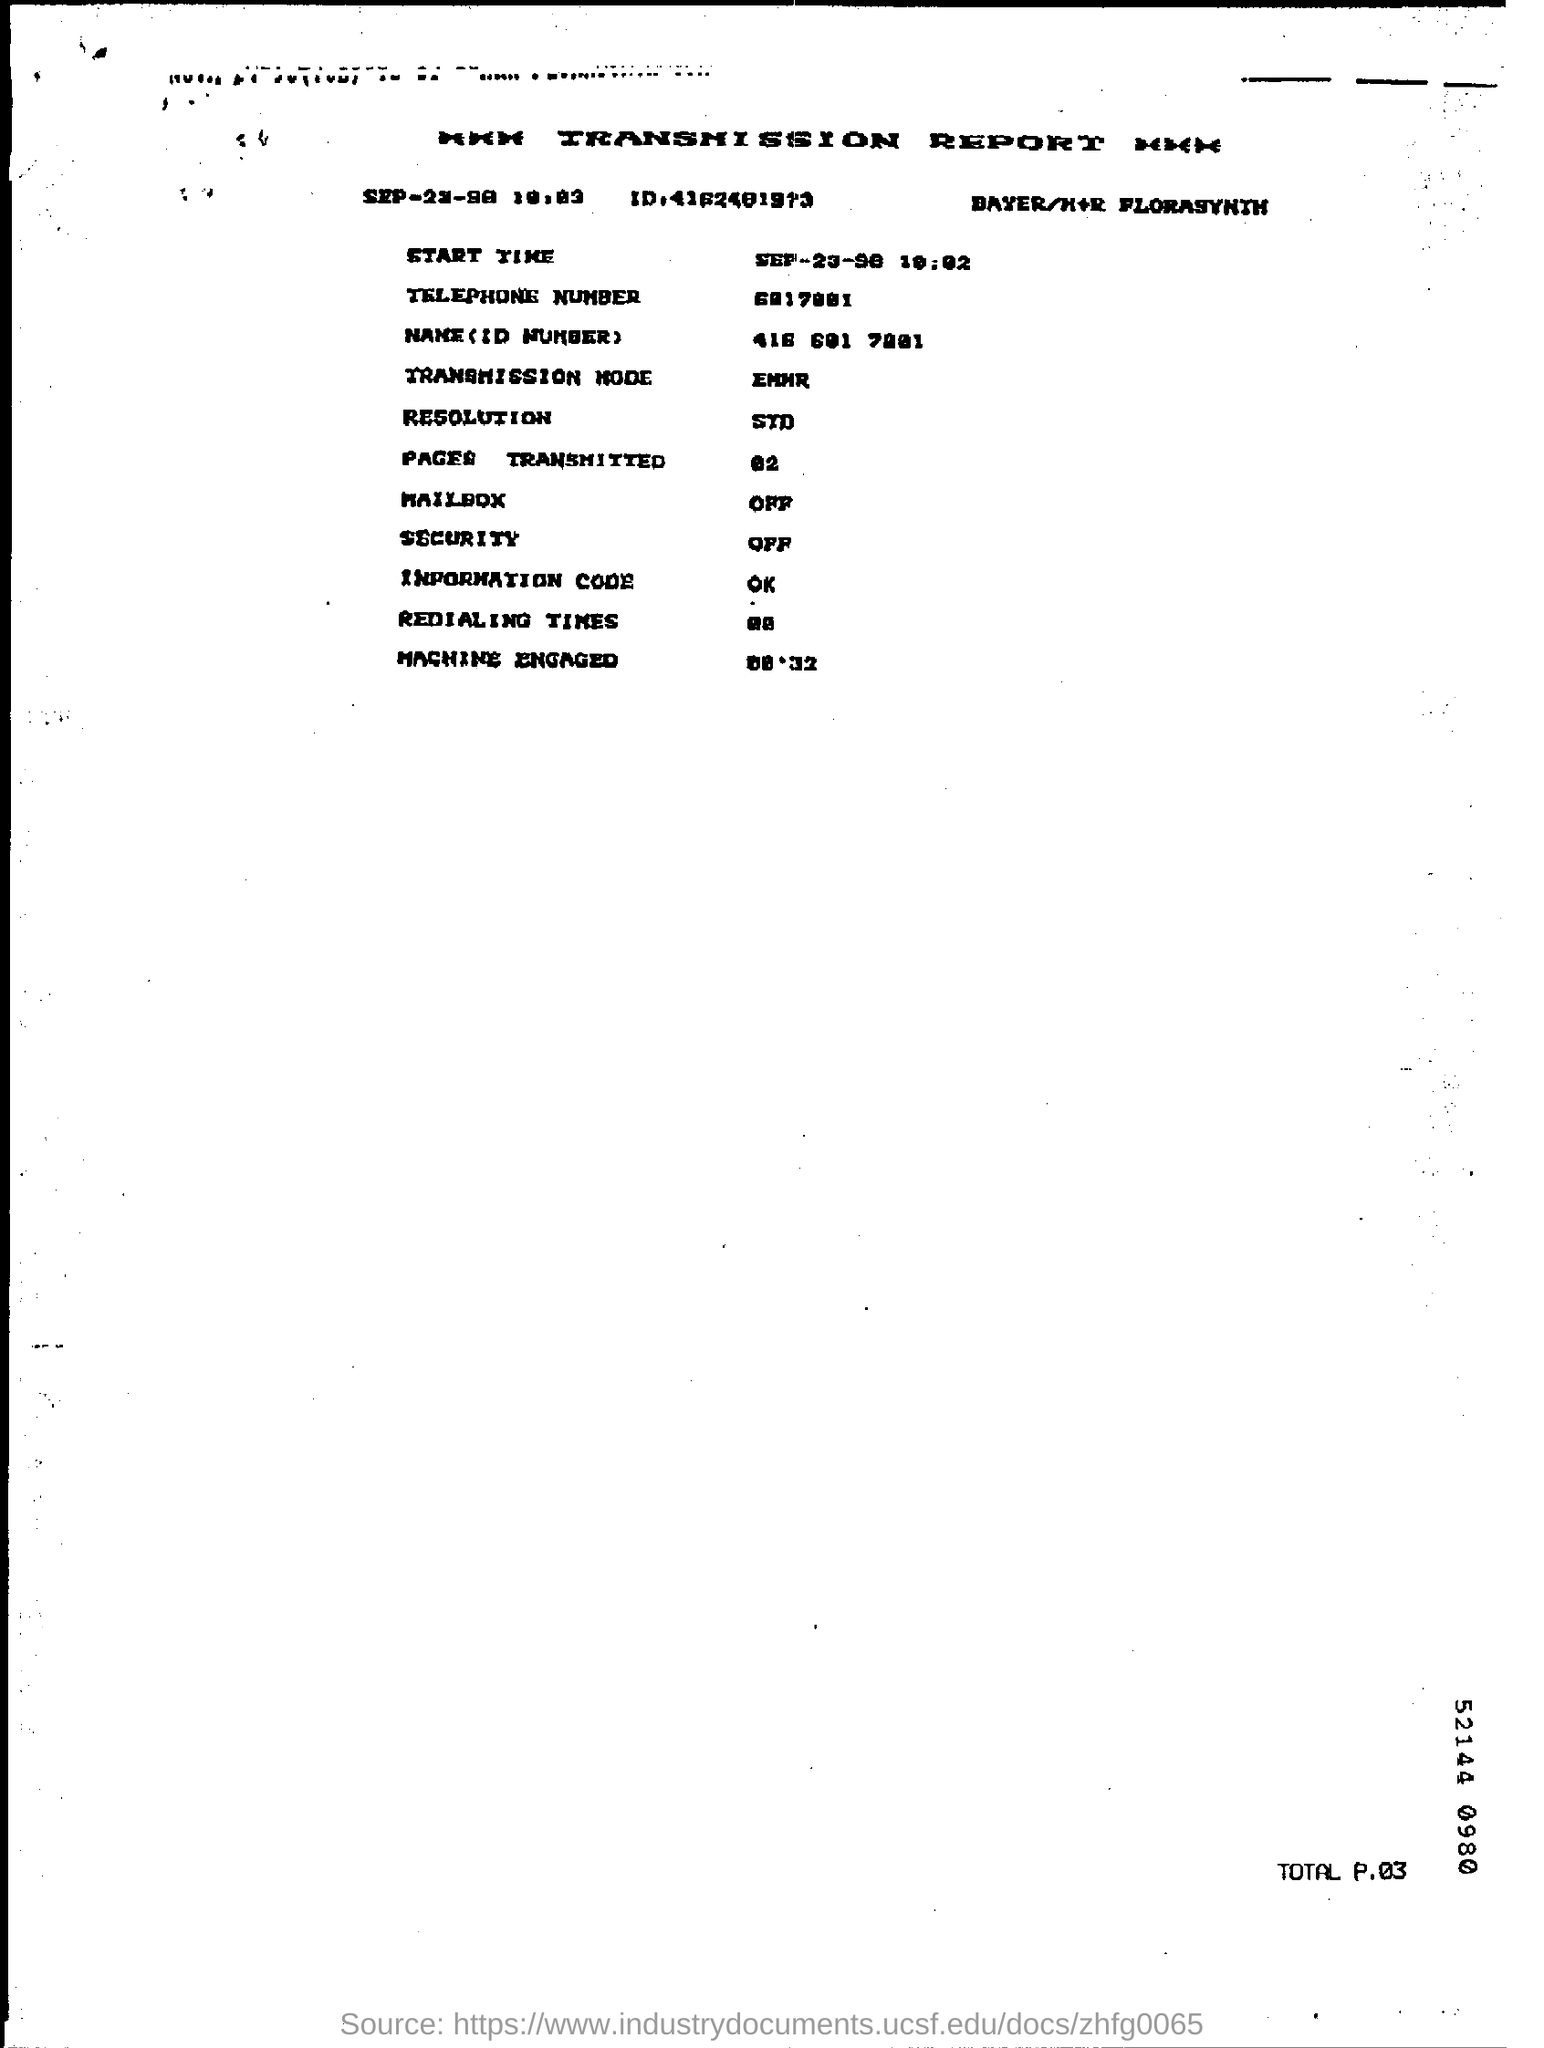What is the Telephone Number?
Keep it short and to the point. 6017001. What is the Transmission Mode?
Your answer should be compact. EMMR. What is the Resolution?
Make the answer very short. STD. What are the Pages Transmitted?
Your response must be concise. 02. What is the Information Code?
Your answer should be very brief. Ok. What is the Security?
Offer a terse response. OFF. What is the Mailbox?
Provide a short and direct response. OFF. 